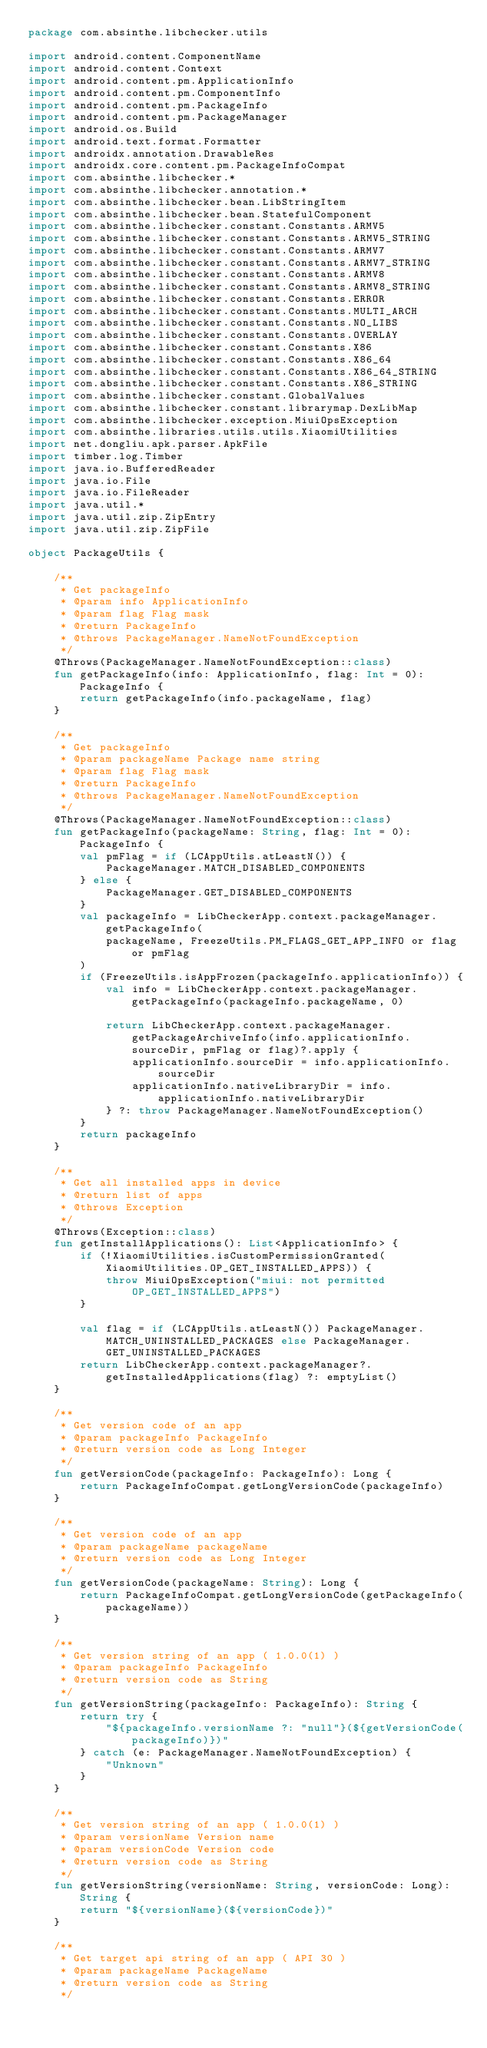Convert code to text. <code><loc_0><loc_0><loc_500><loc_500><_Kotlin_>package com.absinthe.libchecker.utils

import android.content.ComponentName
import android.content.Context
import android.content.pm.ApplicationInfo
import android.content.pm.ComponentInfo
import android.content.pm.PackageInfo
import android.content.pm.PackageManager
import android.os.Build
import android.text.format.Formatter
import androidx.annotation.DrawableRes
import androidx.core.content.pm.PackageInfoCompat
import com.absinthe.libchecker.*
import com.absinthe.libchecker.annotation.*
import com.absinthe.libchecker.bean.LibStringItem
import com.absinthe.libchecker.bean.StatefulComponent
import com.absinthe.libchecker.constant.Constants.ARMV5
import com.absinthe.libchecker.constant.Constants.ARMV5_STRING
import com.absinthe.libchecker.constant.Constants.ARMV7
import com.absinthe.libchecker.constant.Constants.ARMV7_STRING
import com.absinthe.libchecker.constant.Constants.ARMV8
import com.absinthe.libchecker.constant.Constants.ARMV8_STRING
import com.absinthe.libchecker.constant.Constants.ERROR
import com.absinthe.libchecker.constant.Constants.MULTI_ARCH
import com.absinthe.libchecker.constant.Constants.NO_LIBS
import com.absinthe.libchecker.constant.Constants.OVERLAY
import com.absinthe.libchecker.constant.Constants.X86
import com.absinthe.libchecker.constant.Constants.X86_64
import com.absinthe.libchecker.constant.Constants.X86_64_STRING
import com.absinthe.libchecker.constant.Constants.X86_STRING
import com.absinthe.libchecker.constant.GlobalValues
import com.absinthe.libchecker.constant.librarymap.DexLibMap
import com.absinthe.libchecker.exception.MiuiOpsException
import com.absinthe.libraries.utils.utils.XiaomiUtilities
import net.dongliu.apk.parser.ApkFile
import timber.log.Timber
import java.io.BufferedReader
import java.io.File
import java.io.FileReader
import java.util.*
import java.util.zip.ZipEntry
import java.util.zip.ZipFile

object PackageUtils {

    /**
     * Get packageInfo
     * @param info ApplicationInfo
     * @param flag Flag mask
     * @return PackageInfo
     * @throws PackageManager.NameNotFoundException
     */
    @Throws(PackageManager.NameNotFoundException::class)
    fun getPackageInfo(info: ApplicationInfo, flag: Int = 0): PackageInfo {
        return getPackageInfo(info.packageName, flag)
    }

    /**
     * Get packageInfo
     * @param packageName Package name string
     * @param flag Flag mask
     * @return PackageInfo
     * @throws PackageManager.NameNotFoundException
     */
    @Throws(PackageManager.NameNotFoundException::class)
    fun getPackageInfo(packageName: String, flag: Int = 0): PackageInfo {
        val pmFlag = if (LCAppUtils.atLeastN()) {
            PackageManager.MATCH_DISABLED_COMPONENTS
        } else {
            PackageManager.GET_DISABLED_COMPONENTS
        }
        val packageInfo = LibCheckerApp.context.packageManager.getPackageInfo(
            packageName, FreezeUtils.PM_FLAGS_GET_APP_INFO or flag or pmFlag
        )
        if (FreezeUtils.isAppFrozen(packageInfo.applicationInfo)) {
            val info = LibCheckerApp.context.packageManager.getPackageInfo(packageInfo.packageName, 0)

            return LibCheckerApp.context.packageManager.getPackageArchiveInfo(info.applicationInfo.sourceDir, pmFlag or flag)?.apply {
                applicationInfo.sourceDir = info.applicationInfo.sourceDir
                applicationInfo.nativeLibraryDir = info.applicationInfo.nativeLibraryDir
            } ?: throw PackageManager.NameNotFoundException()
        }
        return packageInfo
    }

    /**
     * Get all installed apps in device
     * @return list of apps
     * @throws Exception
     */
    @Throws(Exception::class)
    fun getInstallApplications(): List<ApplicationInfo> {
        if (!XiaomiUtilities.isCustomPermissionGranted(XiaomiUtilities.OP_GET_INSTALLED_APPS)) {
            throw MiuiOpsException("miui: not permitted OP_GET_INSTALLED_APPS")
        }

        val flag = if (LCAppUtils.atLeastN()) PackageManager.MATCH_UNINSTALLED_PACKAGES else PackageManager.GET_UNINSTALLED_PACKAGES
        return LibCheckerApp.context.packageManager?.getInstalledApplications(flag) ?: emptyList()
    }

    /**
     * Get version code of an app
     * @param packageInfo PackageInfo
     * @return version code as Long Integer
     */
    fun getVersionCode(packageInfo: PackageInfo): Long {
        return PackageInfoCompat.getLongVersionCode(packageInfo)
    }

    /**
     * Get version code of an app
     * @param packageName packageName
     * @return version code as Long Integer
     */
    fun getVersionCode(packageName: String): Long {
        return PackageInfoCompat.getLongVersionCode(getPackageInfo(packageName))
    }

    /**
     * Get version string of an app ( 1.0.0(1) )
     * @param packageInfo PackageInfo
     * @return version code as String
     */
    fun getVersionString(packageInfo: PackageInfo): String {
        return try {
            "${packageInfo.versionName ?: "null"}(${getVersionCode(packageInfo)})"
        } catch (e: PackageManager.NameNotFoundException) {
            "Unknown"
        }
    }

    /**
     * Get version string of an app ( 1.0.0(1) )
     * @param versionName Version name
     * @param versionCode Version code
     * @return version code as String
     */
    fun getVersionString(versionName: String, versionCode: Long): String {
        return "${versionName}(${versionCode})"
    }

    /**
     * Get target api string of an app ( API 30 )
     * @param packageName PackageName
     * @return version code as String
     */</code> 